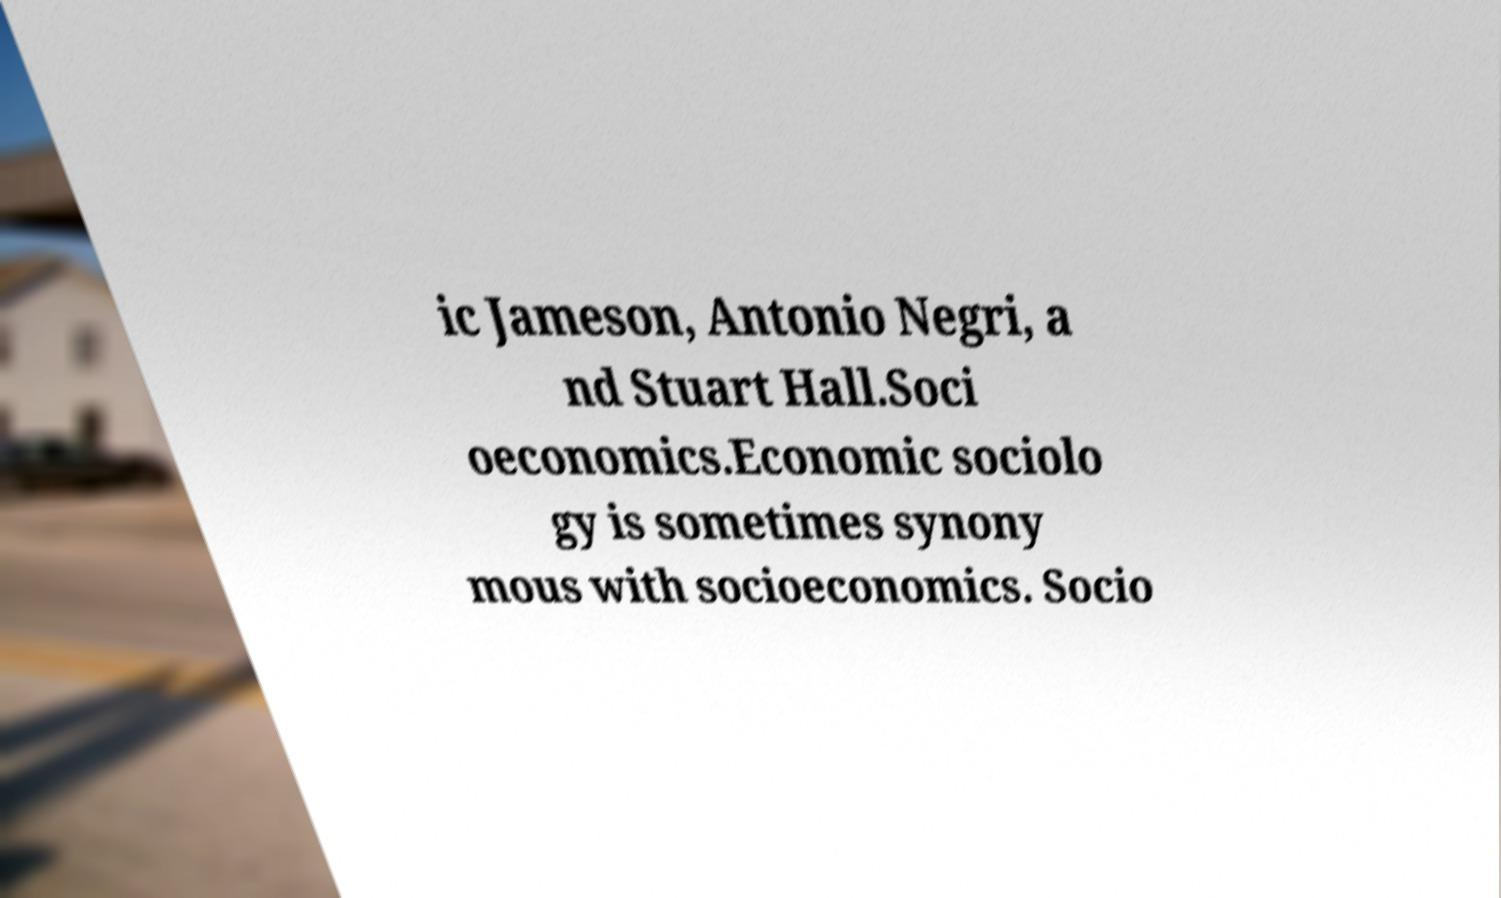Could you extract and type out the text from this image? ic Jameson, Antonio Negri, a nd Stuart Hall.Soci oeconomics.Economic sociolo gy is sometimes synony mous with socioeconomics. Socio 